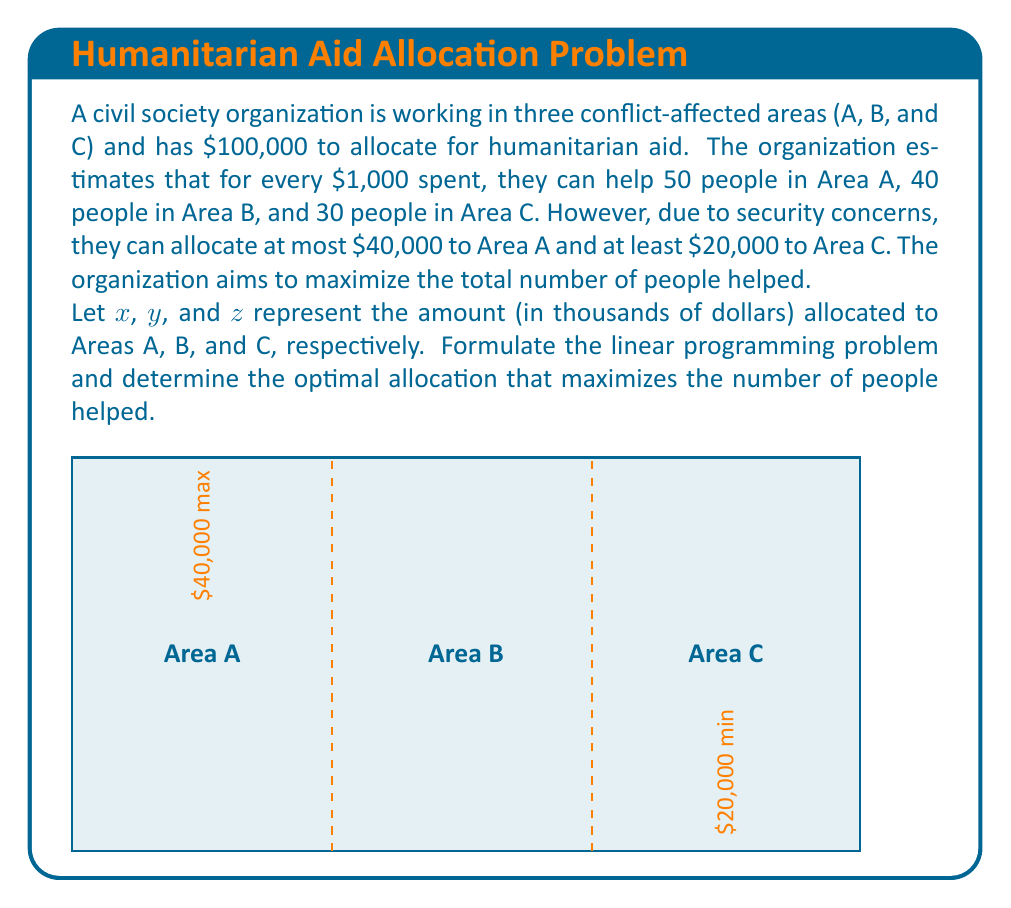Give your solution to this math problem. Let's formulate the linear programming problem step by step:

1) Objective function:
   Maximize $Z = 50x + 40y + 30z$
   (where $Z$ is the total number of people helped)

2) Constraints:
   a) Total budget: $x + y + z \leq 100$
   b) Maximum for Area A: $x \leq 40$
   c) Minimum for Area C: $z \geq 20$
   d) Non-negativity: $x, y, z \geq 0$

3) To solve this, we can use the simplex method or a graphical approach. Given the simplicity, let's use a logical approach:

   - We must allocate at least $20,000 to Area C.
   - Area A has the highest return (50 people/$1,000), so we should allocate the maximum allowed ($40,000) to A.
   - After allocating to A and C, we have $40,000 left for Area B.

4) Therefore, the optimal allocation is:
   $x = 40$, $z = 20$, $y = 40$

5) To verify, let's calculate the total number of people helped:
   $Z = 50(40) + 40(40) + 30(20) = 2000 + 1600 + 600 = 4200$

Thus, the optimal allocation is $40,000 to Area A, $40,000 to Area B, and $20,000 to Area C, helping a total of 4,200 people.
Answer: Optimal allocation: A: $40,000, B: $40,000, C: $20,000; Total helped: 4,200 people 